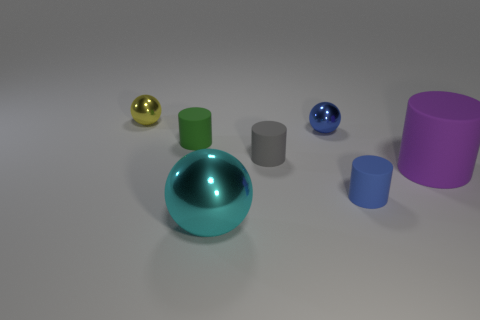What materials do the objects in the image seem to be made of? The cylinders and the ball seem to have a matte finish suggesting a possible rubber or plastic material. The shiny balls, with their reflective surface, appear to be made of a polished metal or a glossy plastic. 